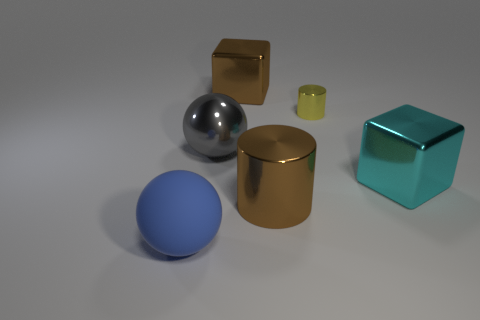Add 1 blue spheres. How many objects exist? 7 Subtract all cubes. How many objects are left? 4 Add 5 big rubber cylinders. How many big rubber cylinders exist? 5 Subtract 0 blue cubes. How many objects are left? 6 Subtract all rubber spheres. Subtract all cyan metal objects. How many objects are left? 4 Add 2 big brown shiny blocks. How many big brown shiny blocks are left? 3 